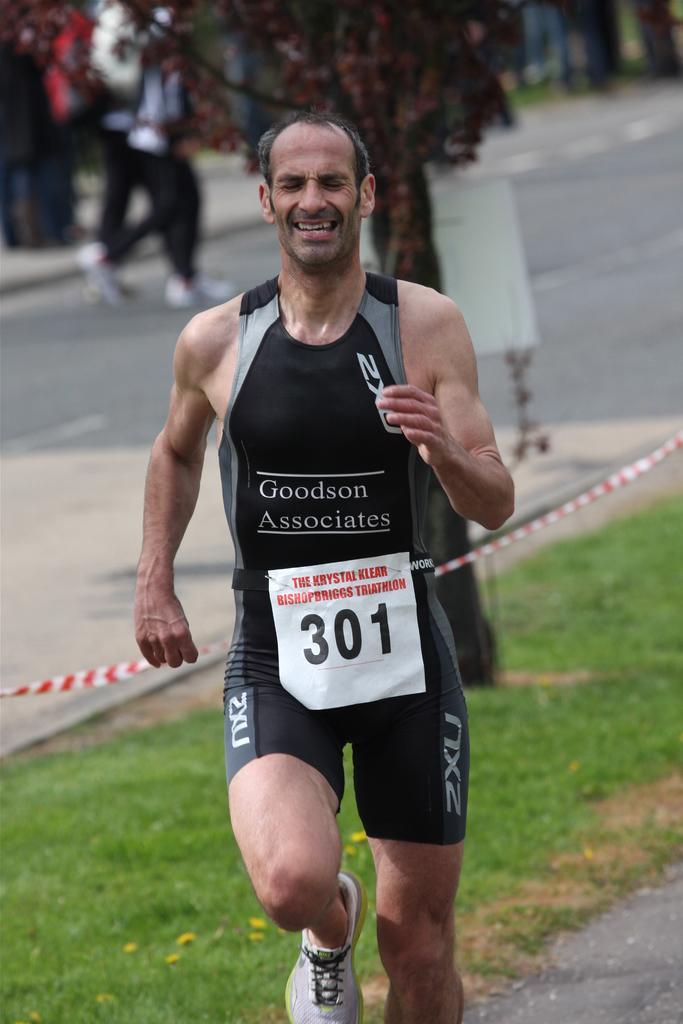<image>
Offer a succinct explanation of the picture presented. A runner with the number 301 on his vest. 